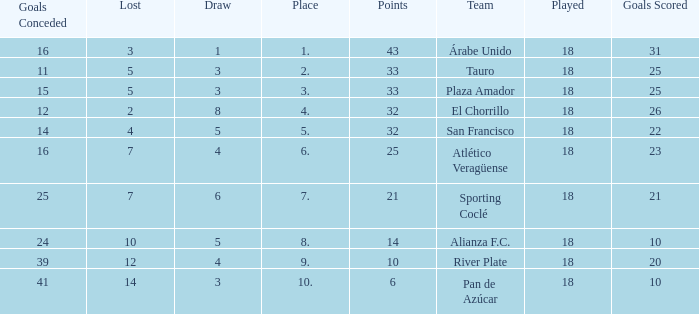How many points did the team have that conceded 41 goals and finish in a place larger than 10? 0.0. Would you mind parsing the complete table? {'header': ['Goals Conceded', 'Lost', 'Draw', 'Place', 'Points', 'Team', 'Played', 'Goals Scored'], 'rows': [['16', '3', '1', '1.', '43', 'Árabe Unido', '18', '31'], ['11', '5', '3', '2.', '33', 'Tauro', '18', '25'], ['15', '5', '3', '3.', '33', 'Plaza Amador', '18', '25'], ['12', '2', '8', '4.', '32', 'El Chorrillo', '18', '26'], ['14', '4', '5', '5.', '32', 'San Francisco', '18', '22'], ['16', '7', '4', '6.', '25', 'Atlético Veragüense', '18', '23'], ['25', '7', '6', '7.', '21', 'Sporting Coclé', '18', '21'], ['24', '10', '5', '8.', '14', 'Alianza F.C.', '18', '10'], ['39', '12', '4', '9.', '10', 'River Plate', '18', '20'], ['41', '14', '3', '10.', '6', 'Pan de Azúcar', '18', '10']]} 